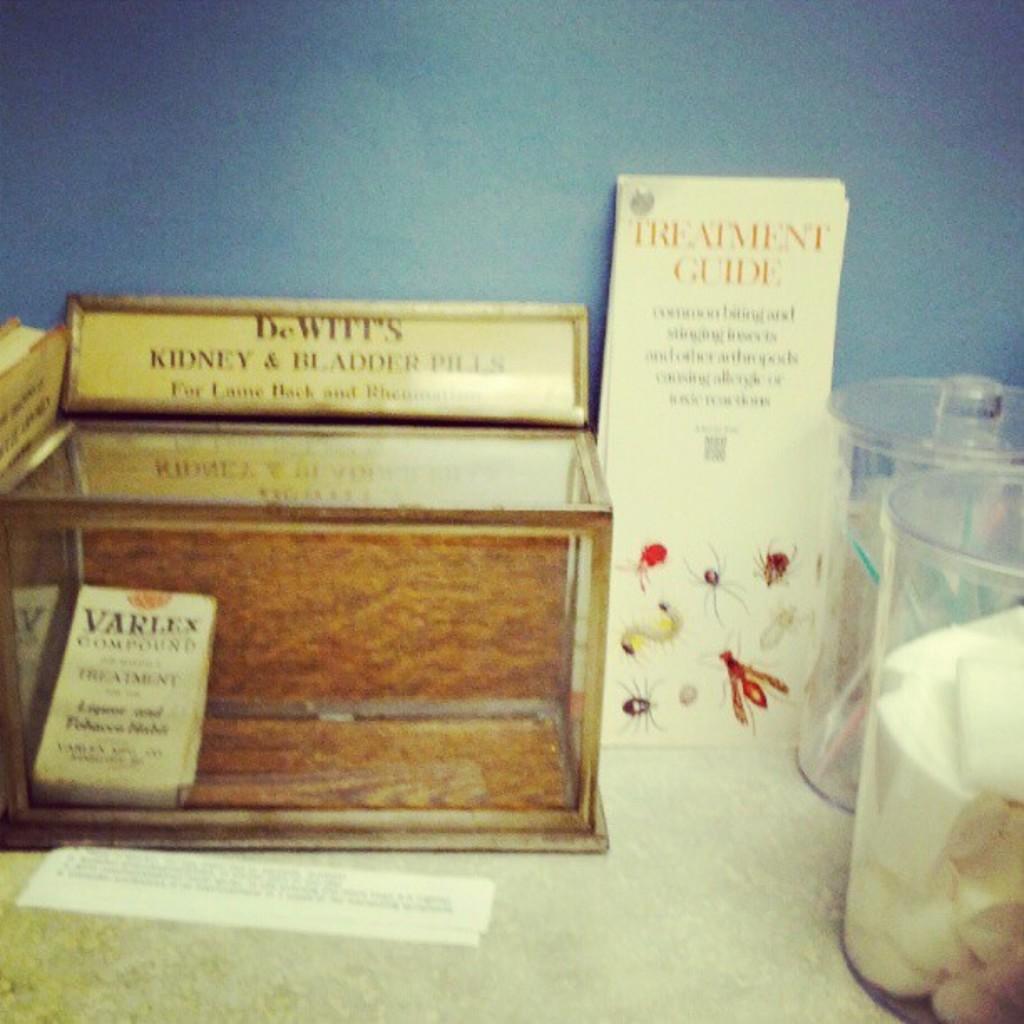What is advertised on the box?
Provide a short and direct response. Kidney and bladder pills. Whats the box about?
Offer a terse response. Kidney and bladder pills. 